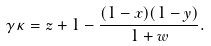Convert formula to latex. <formula><loc_0><loc_0><loc_500><loc_500>\gamma \kappa = z + 1 - \frac { ( 1 - x ) ( 1 - y ) } { 1 + w } .</formula> 